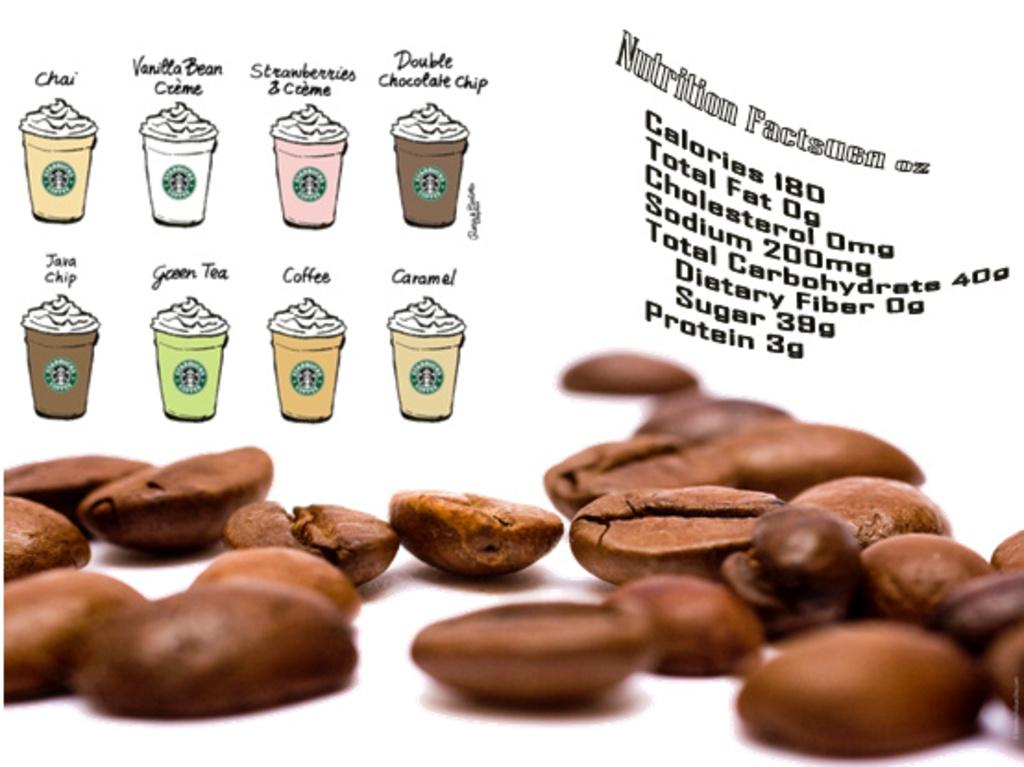What type of image is being described? The image is an edited picture. What can be seen on the white object in the image? There are coffee beans on a white object in the image. What else is present in the image besides the coffee beans? There are cups, words, and numbers in the image. How is the glue being used in the image? There is no glue present in the image. What type of gate can be seen in the image? There is no gate present in the image. 